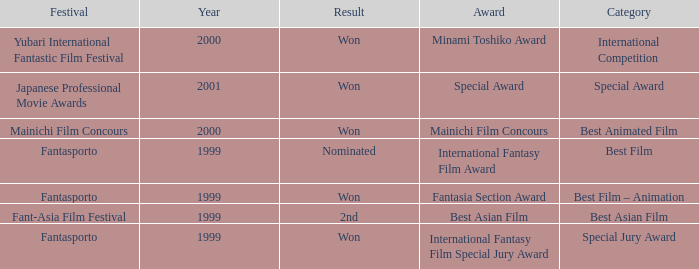What is the average year of the Fantasia Section Award? 1999.0. 